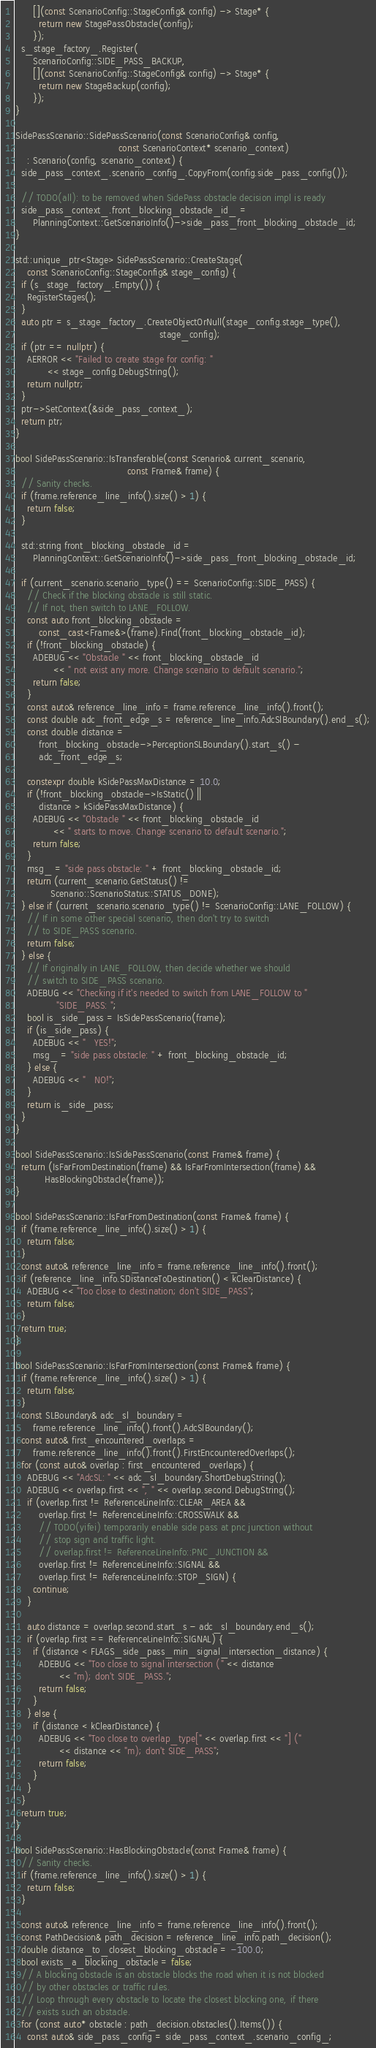Convert code to text. <code><loc_0><loc_0><loc_500><loc_500><_C++_>      [](const ScenarioConfig::StageConfig& config) -> Stage* {
        return new StagePassObstacle(config);
      });
  s_stage_factory_.Register(
      ScenarioConfig::SIDE_PASS_BACKUP,
      [](const ScenarioConfig::StageConfig& config) -> Stage* {
        return new StageBackup(config);
      });
}

SidePassScenario::SidePassScenario(const ScenarioConfig& config,
                                   const ScenarioContext* scenario_context)
    : Scenario(config, scenario_context) {
  side_pass_context_.scenario_config_.CopyFrom(config.side_pass_config());

  // TODO(all): to be removed when SidePass obstacle decision impl is ready
  side_pass_context_.front_blocking_obstacle_id_ =
      PlanningContext::GetScenarioInfo()->side_pass_front_blocking_obstacle_id;
}

std::unique_ptr<Stage> SidePassScenario::CreateStage(
    const ScenarioConfig::StageConfig& stage_config) {
  if (s_stage_factory_.Empty()) {
    RegisterStages();
  }
  auto ptr = s_stage_factory_.CreateObjectOrNull(stage_config.stage_type(),
                                                 stage_config);
  if (ptr == nullptr) {
    AERROR << "Failed to create stage for config: "
           << stage_config.DebugString();
    return nullptr;
  }
  ptr->SetContext(&side_pass_context_);
  return ptr;
}

bool SidePassScenario::IsTransferable(const Scenario& current_scenario,
                                      const Frame& frame) {
  // Sanity checks.
  if (frame.reference_line_info().size() > 1) {
    return false;
  }

  std::string front_blocking_obstacle_id =
      PlanningContext::GetScenarioInfo()->side_pass_front_blocking_obstacle_id;

  if (current_scenario.scenario_type() == ScenarioConfig::SIDE_PASS) {
    // Check if the blocking obstacle is still static.
    // If not, then switch to LANE_FOLLOW.
    const auto front_blocking_obstacle =
        const_cast<Frame&>(frame).Find(front_blocking_obstacle_id);
    if (!front_blocking_obstacle) {
      ADEBUG << "Obstacle " << front_blocking_obstacle_id
             << " not exist any more. Change scenario to default scenario.";
      return false;
    }
    const auto& reference_line_info = frame.reference_line_info().front();
    const double adc_front_edge_s = reference_line_info.AdcSlBoundary().end_s();
    const double distance =
        front_blocking_obstacle->PerceptionSLBoundary().start_s() -
        adc_front_edge_s;

    constexpr double kSidePassMaxDistance = 10.0;
    if (!front_blocking_obstacle->IsStatic() ||
        distance > kSidePassMaxDistance) {
      ADEBUG << "Obstacle " << front_blocking_obstacle_id
             << " starts to move. Change scenario to default scenario.";
      return false;
    }
    msg_ = "side pass obstacle: " + front_blocking_obstacle_id;
    return (current_scenario.GetStatus() !=
            Scenario::ScenarioStatus::STATUS_DONE);
  } else if (current_scenario.scenario_type() != ScenarioConfig::LANE_FOLLOW) {
    // If in some other special scenario, then don't try to switch
    // to SIDE_PASS scenario.
    return false;
  } else {
    // If originally in LANE_FOLLOW, then decide whether we should
    // switch to SIDE_PASS scenario.
    ADEBUG << "Checking if it's needed to switch from LANE_FOLLOW to "
              "SIDE_PASS: ";
    bool is_side_pass = IsSidePassScenario(frame);
    if (is_side_pass) {
      ADEBUG << "   YES!";
      msg_ = "side pass obstacle: " + front_blocking_obstacle_id;
    } else {
      ADEBUG << "   NO!";
    }
    return is_side_pass;
  }
}

bool SidePassScenario::IsSidePassScenario(const Frame& frame) {
  return (IsFarFromDestination(frame) && IsFarFromIntersection(frame) &&
          HasBlockingObstacle(frame));
}

bool SidePassScenario::IsFarFromDestination(const Frame& frame) {
  if (frame.reference_line_info().size() > 1) {
    return false;
  }
  const auto& reference_line_info = frame.reference_line_info().front();
  if (reference_line_info.SDistanceToDestination() < kClearDistance) {
    ADEBUG << "Too close to destination; don't SIDE_PASS";
    return false;
  }
  return true;
}

bool SidePassScenario::IsFarFromIntersection(const Frame& frame) {
  if (frame.reference_line_info().size() > 1) {
    return false;
  }
  const SLBoundary& adc_sl_boundary =
      frame.reference_line_info().front().AdcSlBoundary();
  const auto& first_encountered_overlaps =
      frame.reference_line_info().front().FirstEncounteredOverlaps();
  for (const auto& overlap : first_encountered_overlaps) {
    ADEBUG << "AdcSL: " << adc_sl_boundary.ShortDebugString();
    ADEBUG << overlap.first << ", " << overlap.second.DebugString();
    if (overlap.first != ReferenceLineInfo::CLEAR_AREA &&
        overlap.first != ReferenceLineInfo::CROSSWALK &&
        // TODO(yifei) temporarily enable side pass at pnc junction without
        // stop sign and traffic light.
        // overlap.first != ReferenceLineInfo::PNC_JUNCTION &&
        overlap.first != ReferenceLineInfo::SIGNAL &&
        overlap.first != ReferenceLineInfo::STOP_SIGN) {
      continue;
    }

    auto distance = overlap.second.start_s - adc_sl_boundary.end_s();
    if (overlap.first == ReferenceLineInfo::SIGNAL) {
      if (distance < FLAGS_side_pass_min_signal_intersection_distance) {
        ADEBUG << "Too close to signal intersection (" << distance
               << "m); don't SIDE_PASS.";
        return false;
      }
    } else {
      if (distance < kClearDistance) {
        ADEBUG << "Too close to overlap_type[" << overlap.first << "] ("
               << distance << "m); don't SIDE_PASS";
        return false;
      }
    }
  }
  return true;
}

bool SidePassScenario::HasBlockingObstacle(const Frame& frame) {
  // Sanity checks.
  if (frame.reference_line_info().size() > 1) {
    return false;
  }

  const auto& reference_line_info = frame.reference_line_info().front();
  const PathDecision& path_decision = reference_line_info.path_decision();
  double distance_to_closest_blocking_obstacle = -100.0;
  bool exists_a_blocking_obstacle = false;
  // A blocking obstacle is an obstacle blocks the road when it is not blocked
  // by other obstacles or traffic rules.
  // Loop through every obstacle to locate the closest blocking one, if there
  // exists such an obstacle.
  for (const auto* obstacle : path_decision.obstacles().Items()) {
    const auto& side_pass_config = side_pass_context_.scenario_config_;</code> 